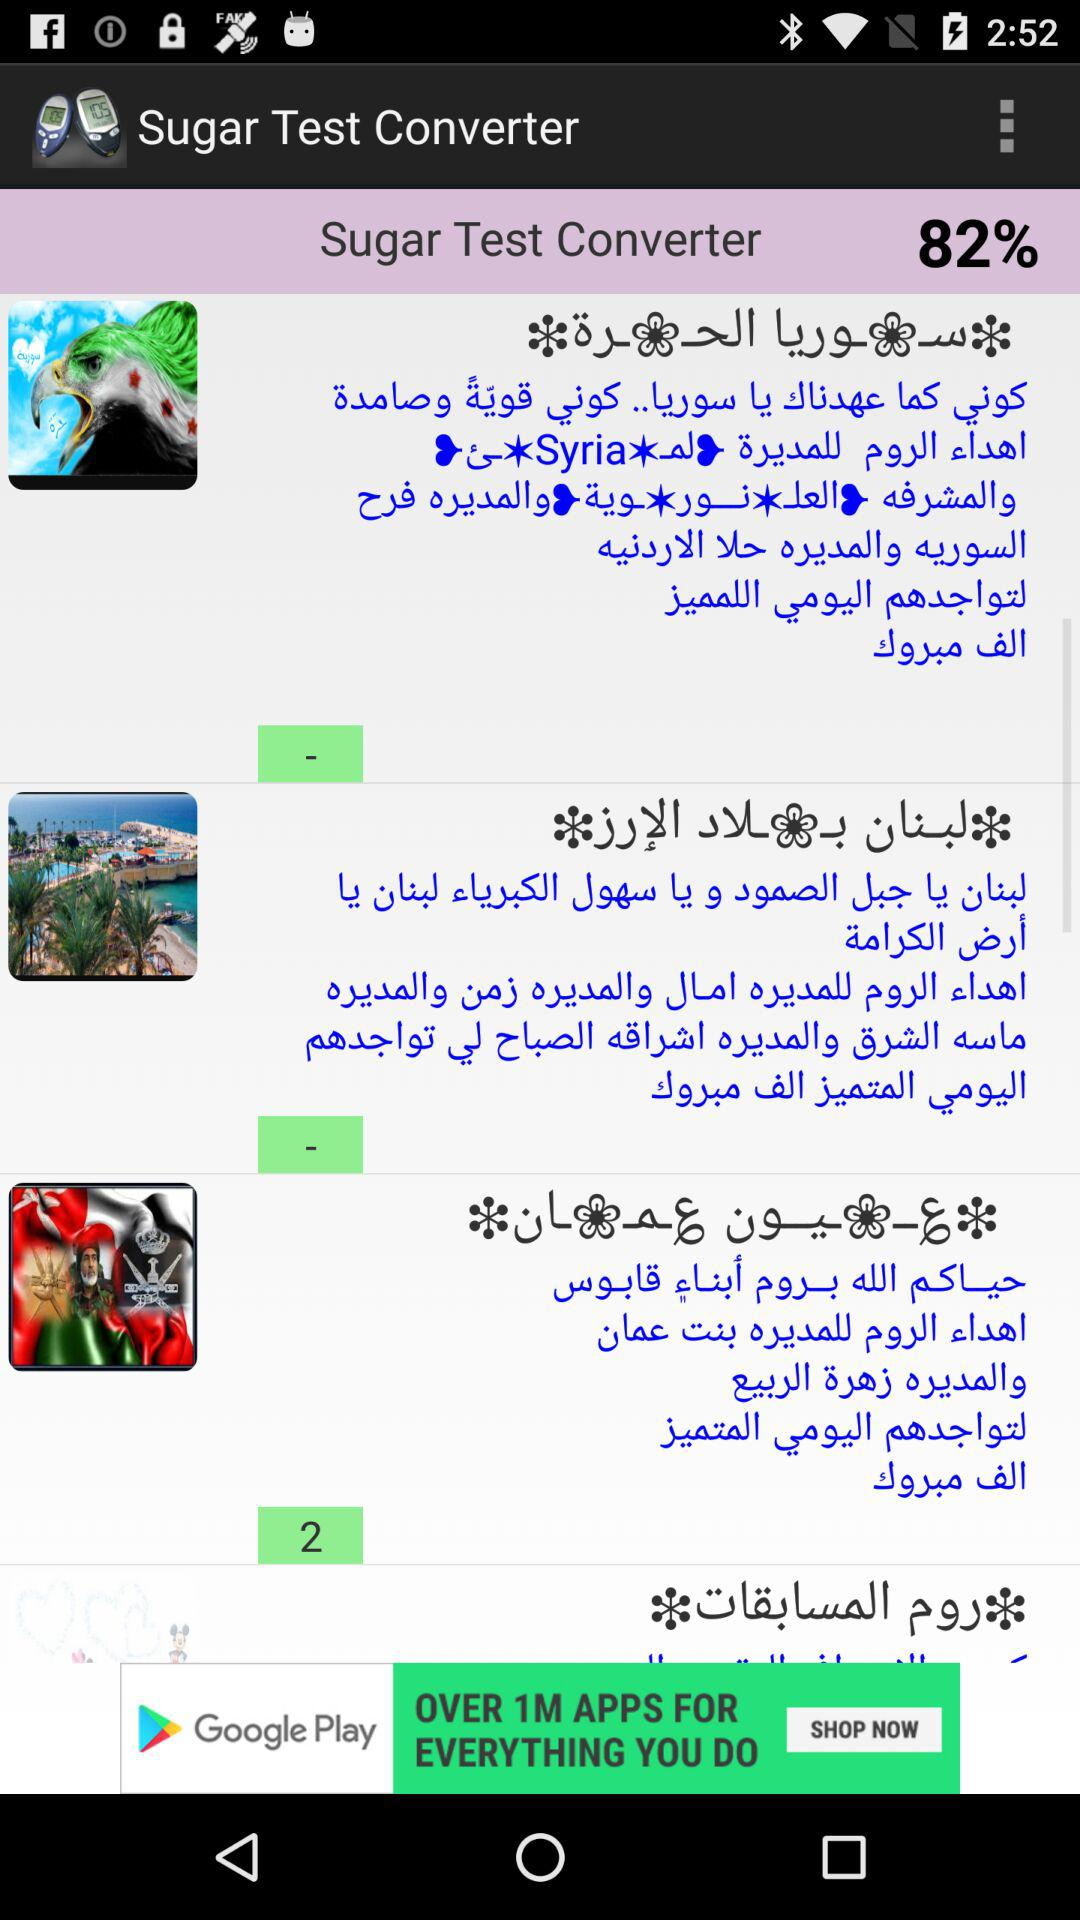What is the application name? The application name is "Sugar Test Converter". 